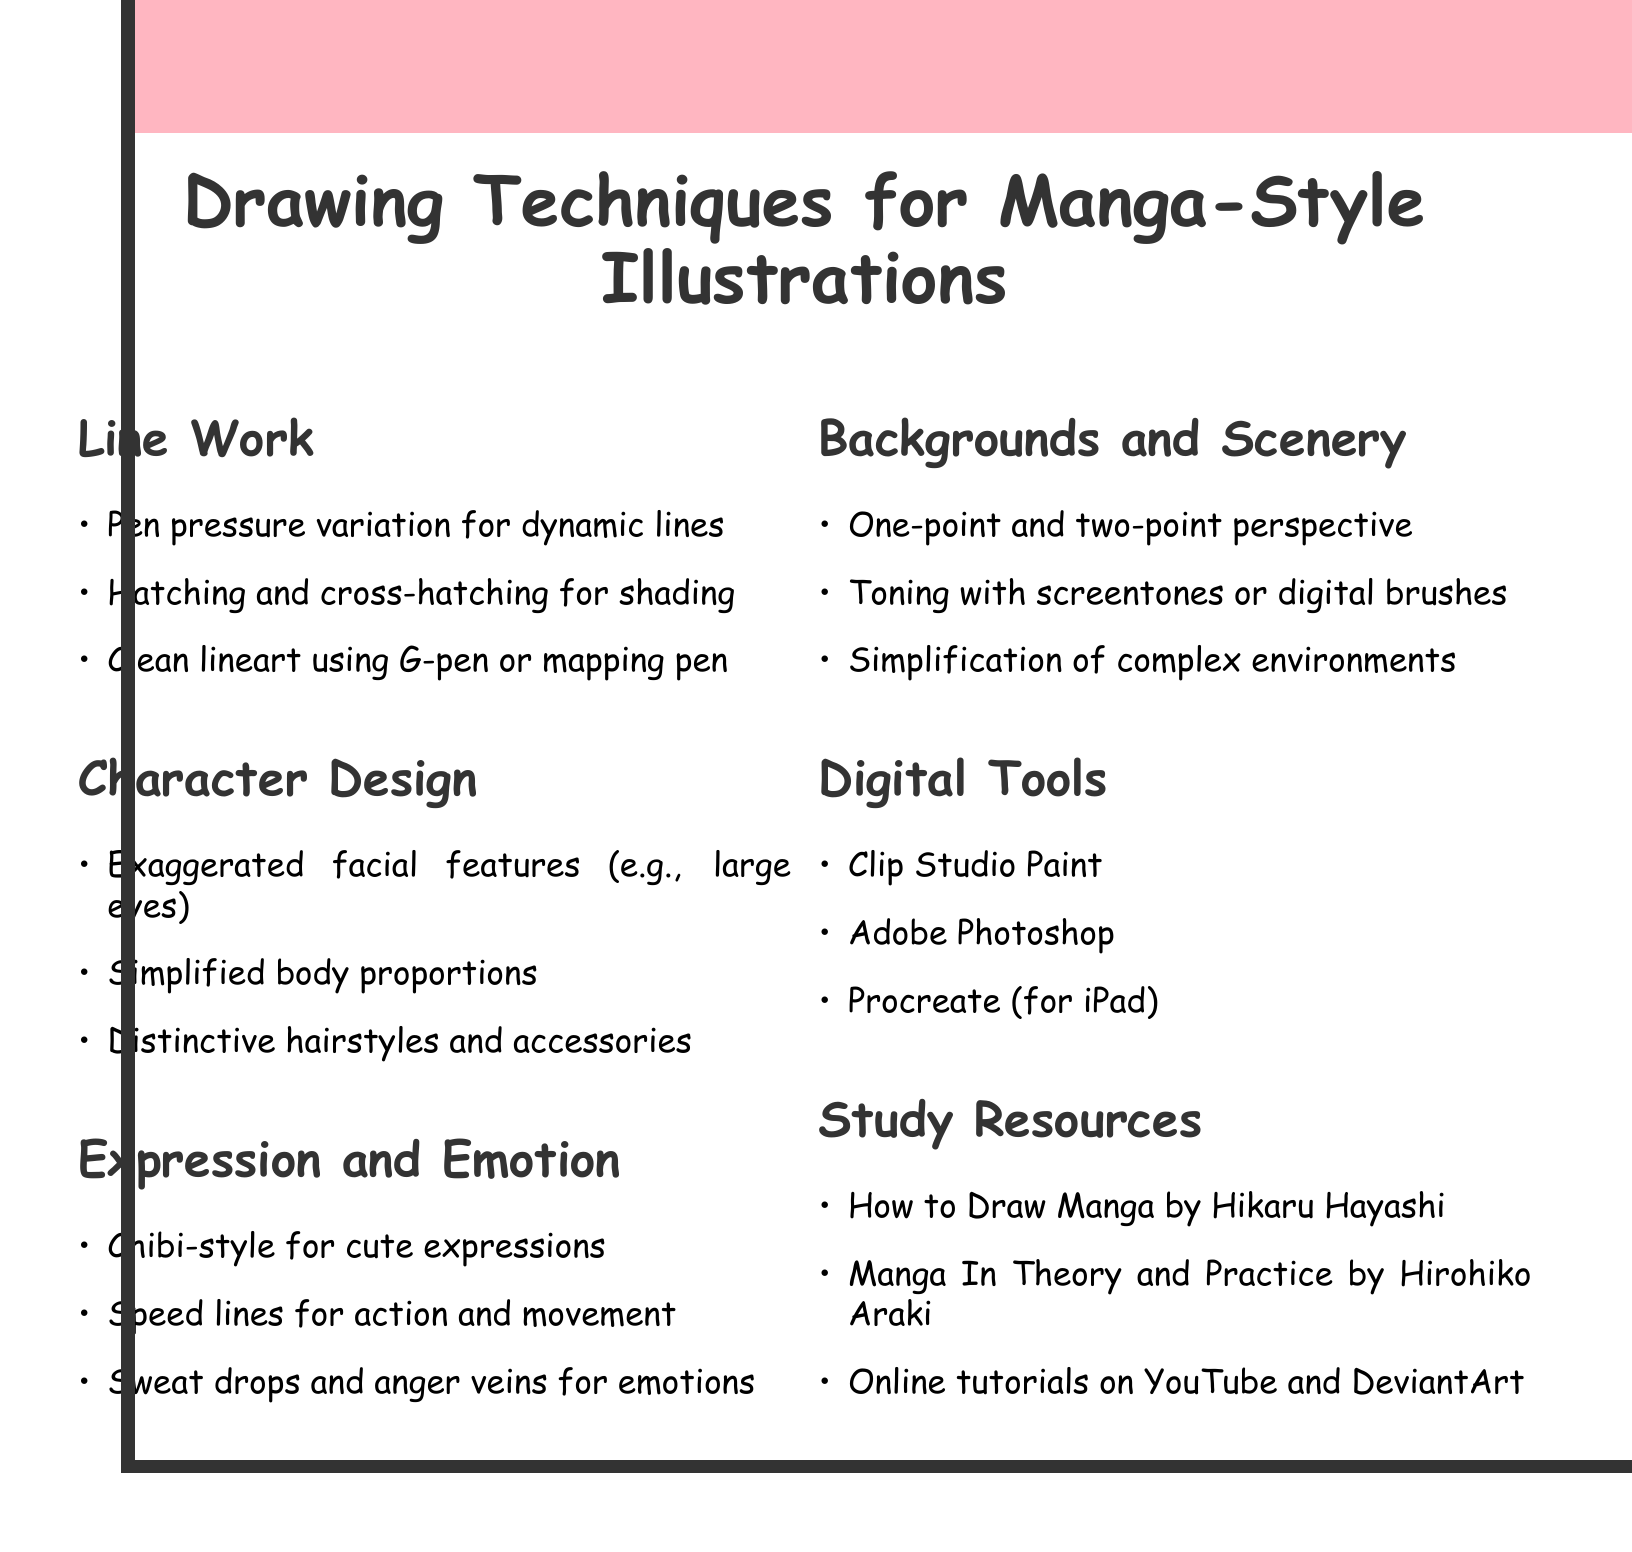what are the techniques used in Line Work? The techniques listed under Line Work include pen pressure variation, hatching, cross-hatching, and clean lineart.
Answer: Pen pressure variation for dynamic lines, Hatching and cross-hatching for shading, Clean lineart using G-pen or mapping pen what are the software tools mentioned? The document lists three software tools relevant for digital illustration.
Answer: Clip Studio Paint, Adobe Photoshop, Procreate (for iPad) which section focuses on character features? The section that emphasizes character features, particularly facial features and body proportions, is dedicated to Character Design.
Answer: Character Design what is one technique for creating emotions? One of the techniques listed for portraying emotions includes using sweat drops and anger veins.
Answer: Sweat drops and anger veins for emotions who is the author of "Manga In Theory and Practice"? The author of this study resource is mentioned in the document.
Answer: Hirohiko Araki what kind of perspective techniques are noted for backgrounds? The document specifies types of perspective techniques beneficial for illustrating backgrounds.
Answer: One-point and two-point perspective what style is suggested for cute expressions? The document recommends a specific style for capturing cute expressions, which is discussed in the Expression and Emotion section.
Answer: Chibi-style what is a characteristic of manga hairstyles? A distinctive aspect of hairstyles in manga character design is highlighted in the techniques.
Answer: Distinctive hairstyles and accessories 